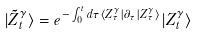Convert formula to latex. <formula><loc_0><loc_0><loc_500><loc_500>| \tilde { Z } _ { t } ^ { \gamma } \rangle = e ^ { - \int _ { 0 } ^ { t } d \tau \langle Z _ { \tau } ^ { \gamma } | \partial _ { \tau } | Z _ { \tau } ^ { \gamma } \rangle } | Z _ { t } ^ { \gamma } \rangle</formula> 